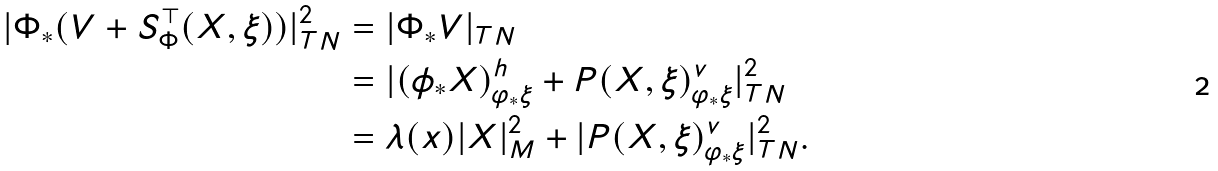Convert formula to latex. <formula><loc_0><loc_0><loc_500><loc_500>| \Phi _ { \ast } ( V + S ^ { \top } _ { \Phi } ( X , \xi ) ) | _ { T N } ^ { 2 } & = | \Phi _ { \ast } V | _ { T N } \\ & = | ( \phi _ { \ast } X ) ^ { h } _ { \varphi _ { \ast } \xi } + P ( X , \xi ) ^ { v } _ { \varphi _ { \ast } \xi } | _ { T N } ^ { 2 } \\ & = \lambda ( x ) | X | _ { M } ^ { 2 } + | P ( X , \xi ) ^ { v } _ { \varphi _ { \ast } \xi } | _ { T N } ^ { 2 } .</formula> 